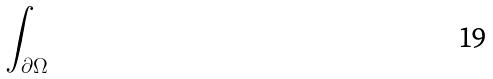Convert formula to latex. <formula><loc_0><loc_0><loc_500><loc_500>\int _ { \partial \Omega }</formula> 